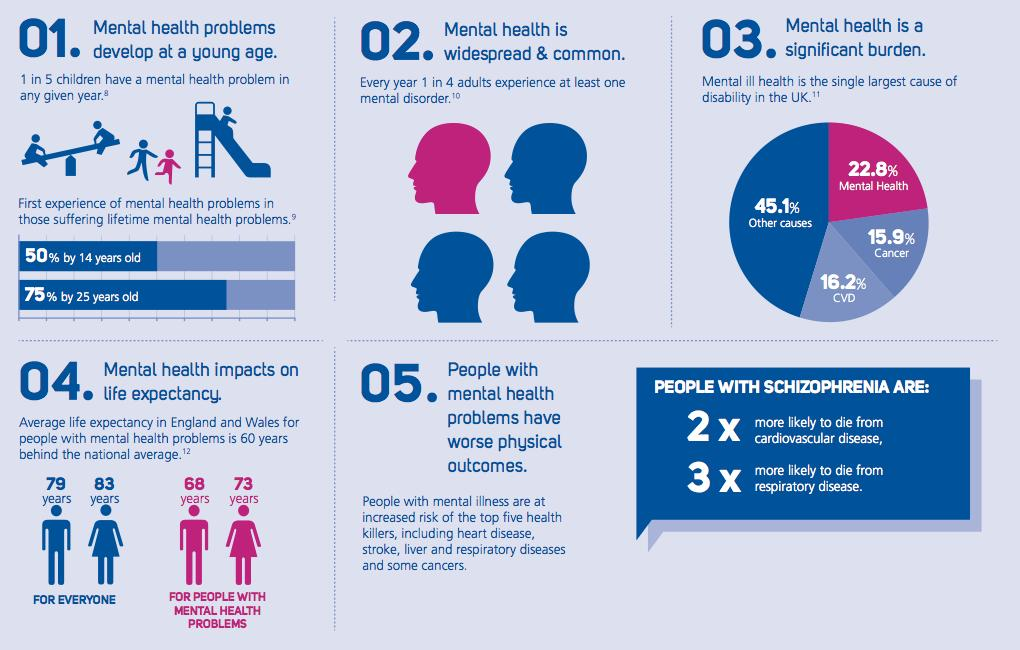Outline some significant characteristics in this image. Women have a higher life expectancy than men with mental health problems. In the UK, cardiovascular disease (CVD) is the leading cause of disability after mental health. It is estimated that half of all teenagers will experience mental health problems by the time they reach their teenage years. According to recent research, only 25% of adults are not prone to at least one mental health disorder. The average life expectancy for a woman with mental health problems in England and Wales is 73 years. 